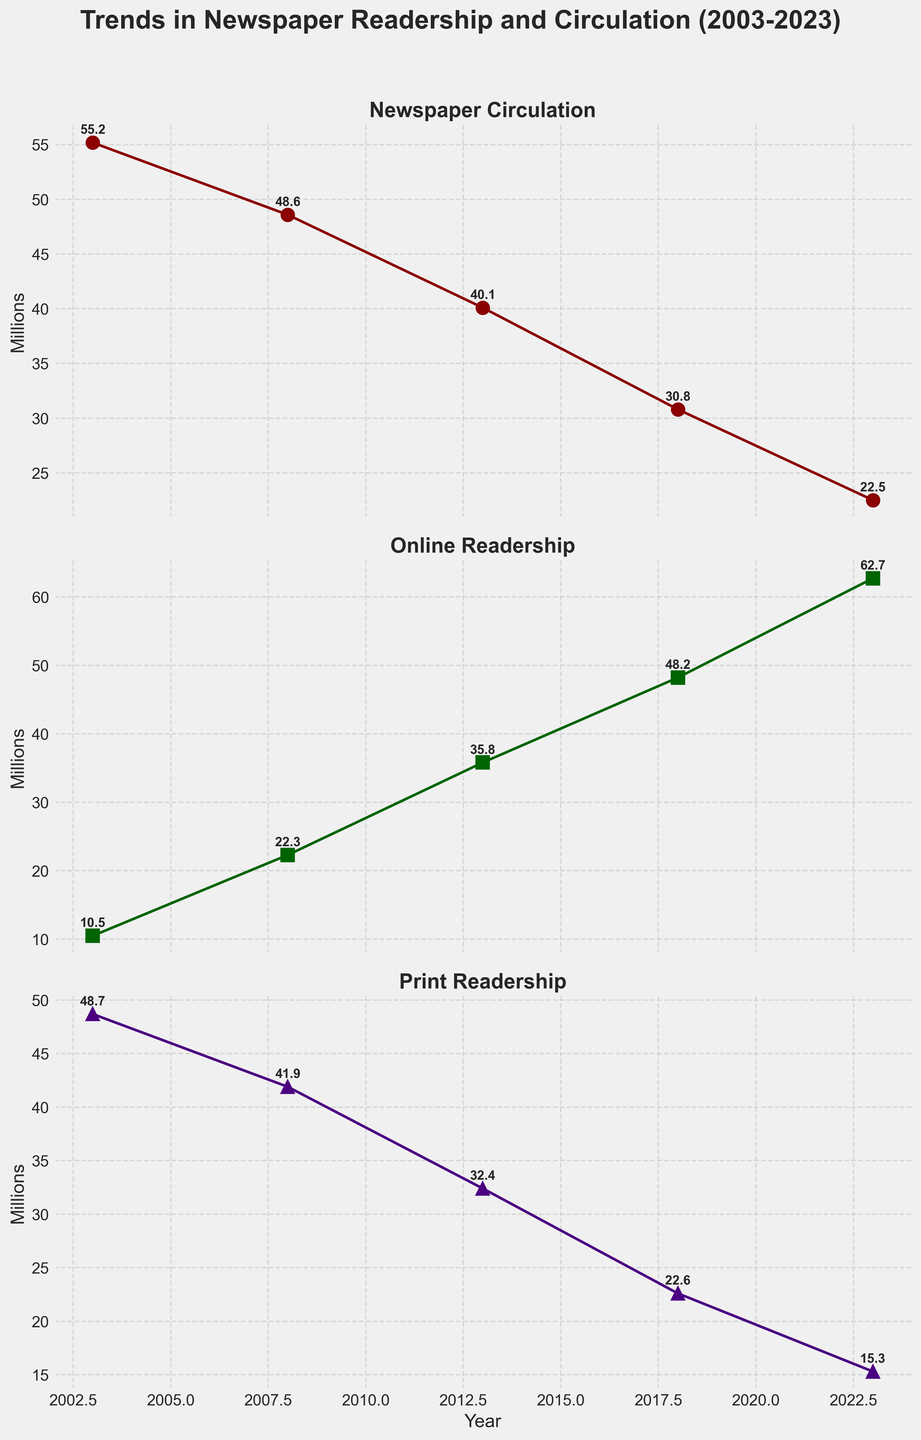What trend can you observe in the newspaper circulation over the years? The newspaper circulation shows a declining trend from 55.2 million in 2003 to 22.5 million in 2023. The line steadily decreases over the 20-year period indicating less circulation of physical newspapers.
Answer: Declining What was the highest online readership recorded in the data? Looking at the Online Readership subplot, the highest online readership recorded is in 2023 with a value of 62.7 million.
Answer: 62.7 million How does print readership in 2003 compare to that in 2023? In 2003, the print readership was 48.7 million, whereas in 2023 it was 15.3 million. The print readership decreased significantly over the 20 years.
Answer: Decreased significantly Which year shows the greatest increase in online readership compared to the previous recorded year? To determine this, we need to calculate the differences in online readership between consecutive years: 2008-2003 (22.3-10.5=11.8), 2013-2008 (35.8-22.3=13.5), 2018-2013 (48.2-35.8=12.4), 2023-2018 (62.7-48.2=14.5). The greatest increase is between 2018 and 2023, with an increase of 14.5 million.
Answer: 2018 to 2023 By approximately what percentage did circulation decrease from 2003 to 2023? First, calculate the decrease in circulation: 55.2 - 22.5 = 32.7 million. Then, calculate the percentage decrease: (32.7/55.2) * 100 ≈ 59.2%.
Answer: 59.2% In which period was the decline in print readership the steepest? Calculating the declines between consecutive years for print readership: 2008-2003 (48.7-41.9=6.8), 2013-2008 (41.9-32.4=9.5), 2018-2013 (32.4-22.6=9.8), 2023-2018 (22.6-15.3=7.3). The steepest decline happened between 2013 and 2018 with a decrease of 9.8 million.
Answer: 2013 to 2018 What was the readership split (online vs. print) in 2018? In 2018, the online readership was 48.2 million and the print readership was 22.6 million. Therefore, the readership split is 48.2 million online vs. 22.6 million print.
Answer: 48.2 million online / 22.6 million print Calculate the average circulation over the 20-year period. Average circulation is calculated by summing up the circulation values and dividing by the number of data points: (55.2 + 48.6 + 40.1 + 30.8 + 22.5) / 5 = 39.44 million.
Answer: 39.44 million How much did the online readership increase from 2003 to 2023? Online readership in 2003 was 10.5 million and in 2023 it was 62.7 million. The increase is calculated as 62.7 - 10.5 = 52.2 million.
Answer: 52.2 million 